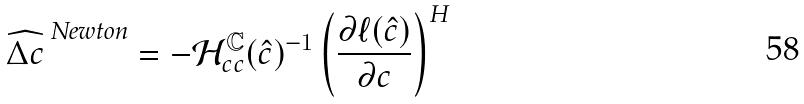<formula> <loc_0><loc_0><loc_500><loc_500>\widehat { \Delta { c } } ^ { \text { Newton} } = - \mathcal { H } _ { c c } ^ { \text {\boldmath $\mathbb{C}$} } ( \hat { c } ) ^ { - 1 } \left ( \frac { \partial \ell ( \hat { c } ) } { \partial c } \right ) ^ { H }</formula> 